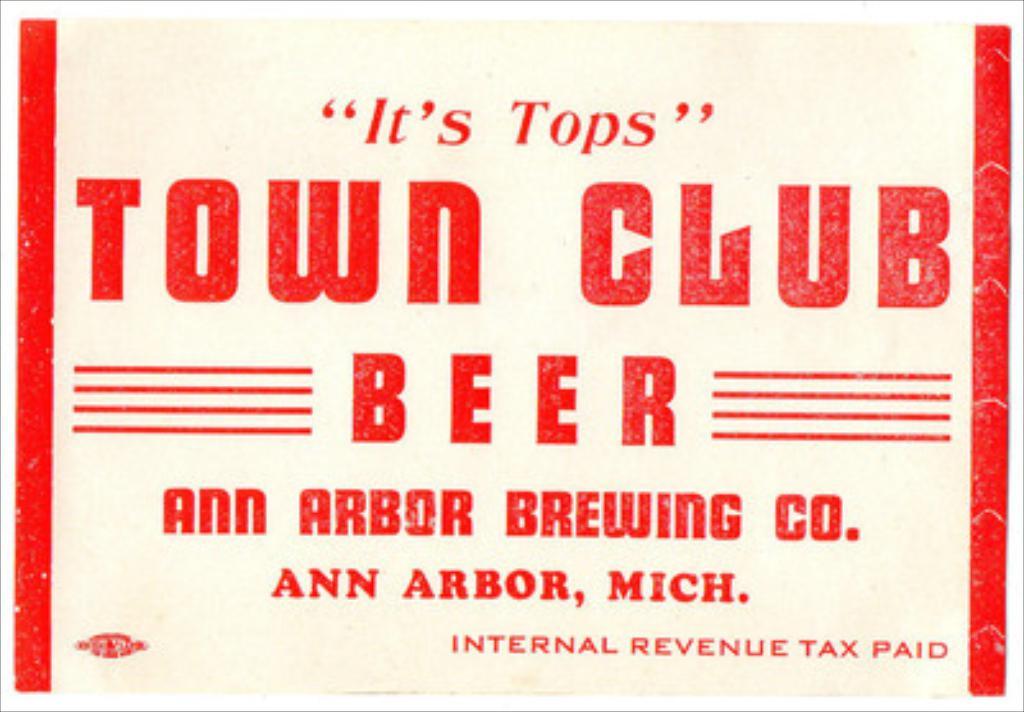Who is the brewing company of the beer?
Your answer should be very brief. Ann arbor brewing co. 